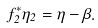<formula> <loc_0><loc_0><loc_500><loc_500>f _ { 2 } ^ { * } \eta _ { 2 } = \eta - \beta .</formula> 